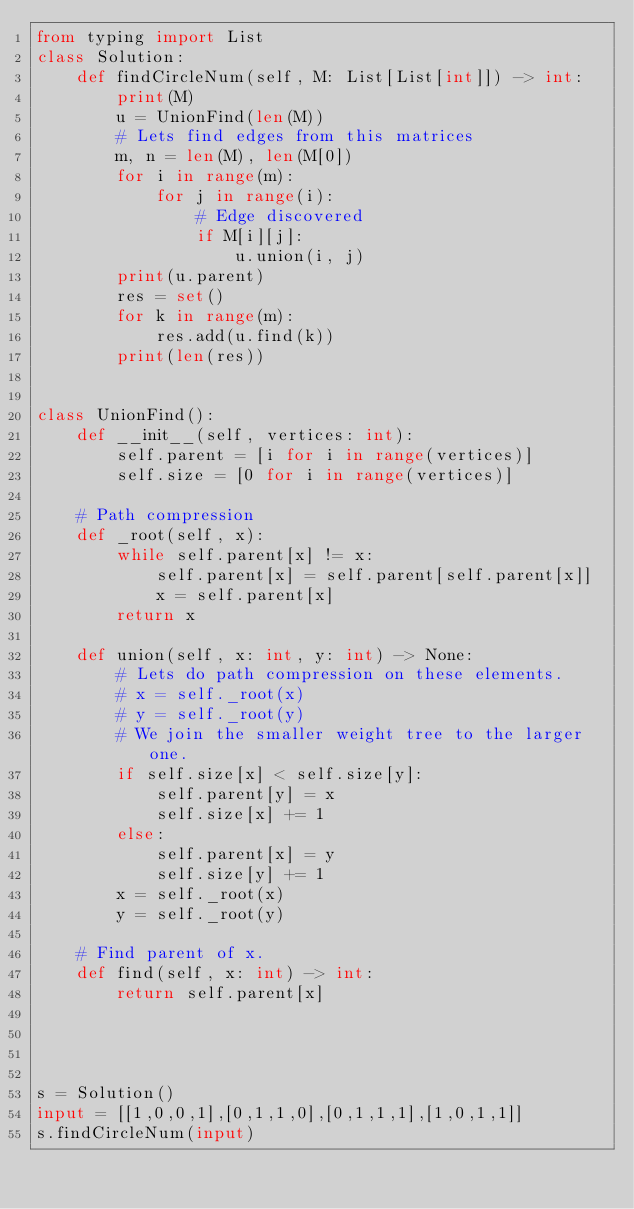Convert code to text. <code><loc_0><loc_0><loc_500><loc_500><_Python_>from typing import List
class Solution:
    def findCircleNum(self, M: List[List[int]]) -> int:
        print(M)
        u = UnionFind(len(M))
        # Lets find edges from this matrices 
        m, n = len(M), len(M[0])
        for i in range(m):
            for j in range(i):
                # Edge discovered
                if M[i][j]:
                    u.union(i, j)
        print(u.parent)
        res = set()
        for k in range(m):
            res.add(u.find(k))
        print(len(res))
                    

class UnionFind():
    def __init__(self, vertices: int):
        self.parent = [i for i in range(vertices)]
        self.size = [0 for i in range(vertices)]

    # Path compression 
    def _root(self, x):
        while self.parent[x] != x:
            self.parent[x] = self.parent[self.parent[x]]
            x = self.parent[x]
        return x

    def union(self, x: int, y: int) -> None:
        # Lets do path compression on these elements. 
        # x = self._root(x)
        # y = self._root(y)
        # We join the smaller weight tree to the larger one. 
        if self.size[x] < self.size[y]:
            self.parent[y] = x
            self.size[x] += 1
        else:
            self.parent[x] = y
            self.size[y] += 1
        x = self._root(x)
        y = self._root(y)
    
    # Find parent of x.
    def find(self, x: int) -> int:
        return self.parent[x]




s = Solution()
input = [[1,0,0,1],[0,1,1,0],[0,1,1,1],[1,0,1,1]]
s.findCircleNum(input)</code> 